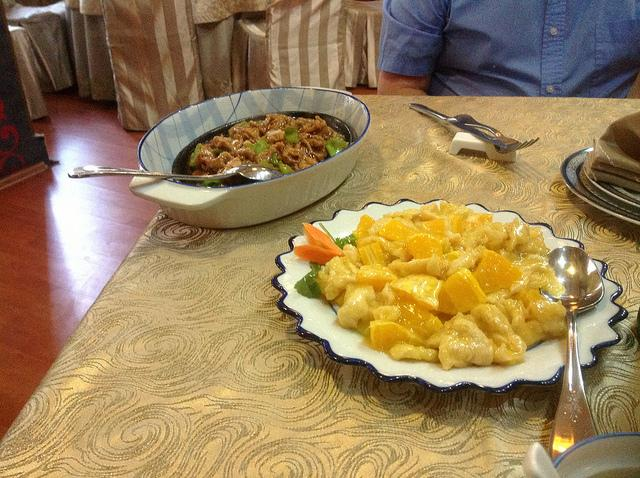What utensil is missing from this table? Please explain your reasoning. knife. There are forks and spoons. 